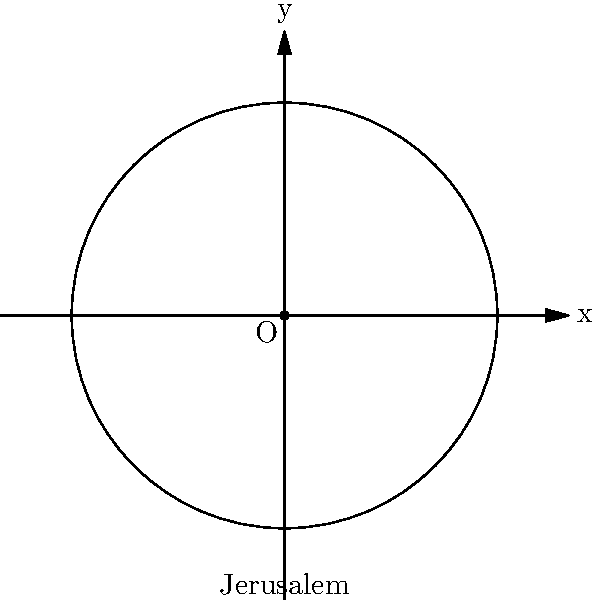The city of Jerusalem, a significant location in religious and political history, can be represented as the center of a circle on a coordinate plane. If the equation of this circle is $x^2 + y^2 = 9$, what is the area of the region enclosed by the circle? Express your answer in terms of $\pi$. To solve this problem, let's follow these steps:

1) The general equation of a circle is $(x - h)^2 + (y - k)^2 = r^2$, where $(h,k)$ is the center and $r$ is the radius.

2) Our equation is $x^2 + y^2 = 9$, which means:
   - The center is at $(0,0)$, representing Jerusalem
   - The radius $r$ satisfies $r^2 = 9$

3) Solving for $r$:
   $r^2 = 9$
   $r = 3$

4) The area of a circle is given by the formula $A = \pi r^2$

5) Substituting $r = 3$:
   $A = \pi (3)^2 = 9\pi$

Therefore, the area of the region enclosed by the circle is $9\pi$ square units.
Answer: $9\pi$ 